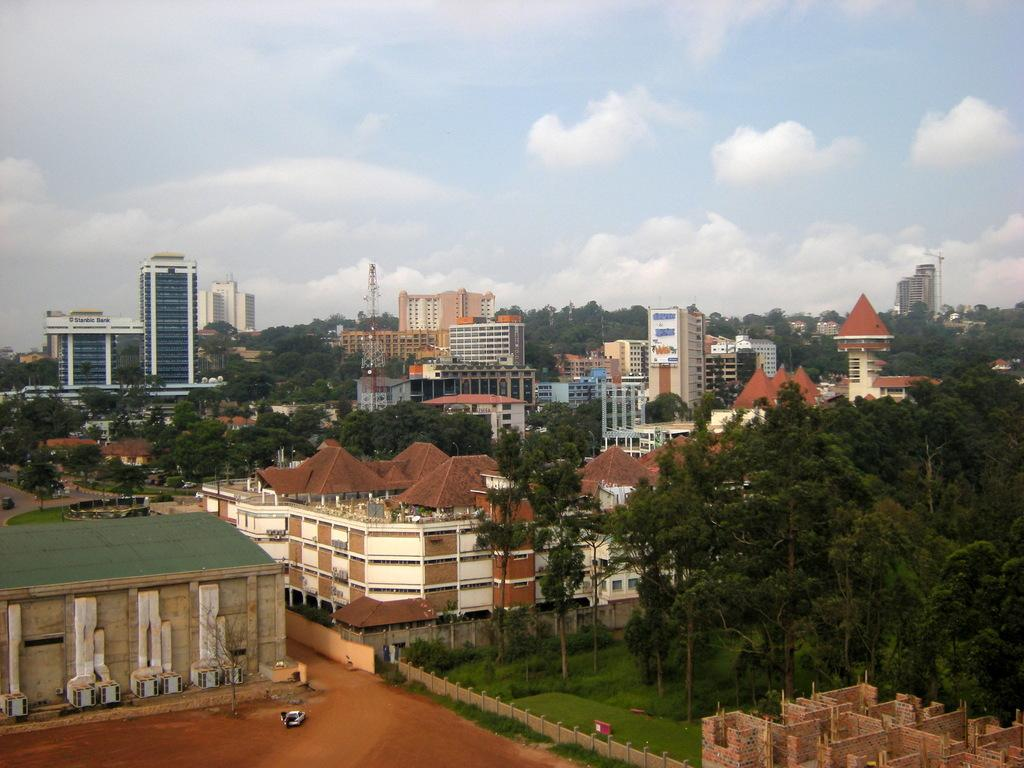What type of structures can be seen in the image? There are buildings in the image. What type of vegetation is visible in the image? There is grass visible in the image. What other natural elements can be seen in the image? There are trees in the image. What is visible in the background of the image? The sky is visible in the image. What can be observed in the sky? Clouds are present in the sky. Who is the creator of the holiday depicted in the image? There is no holiday depicted in the image, so it is not possible to determine who created it. 